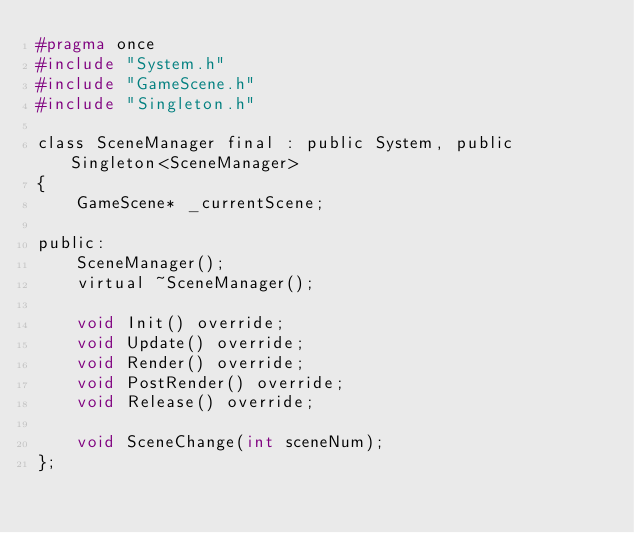Convert code to text. <code><loc_0><loc_0><loc_500><loc_500><_C_>#pragma once
#include "System.h"
#include "GameScene.h"
#include "Singleton.h"

class SceneManager final : public System, public Singleton<SceneManager>
{
	GameScene* _currentScene;

public:
	SceneManager();
	virtual ~SceneManager();

	void Init() override;
	void Update() override;
	void Render() override;
	void PostRender() override;
	void Release() override;

	void SceneChange(int sceneNum);
};

</code> 